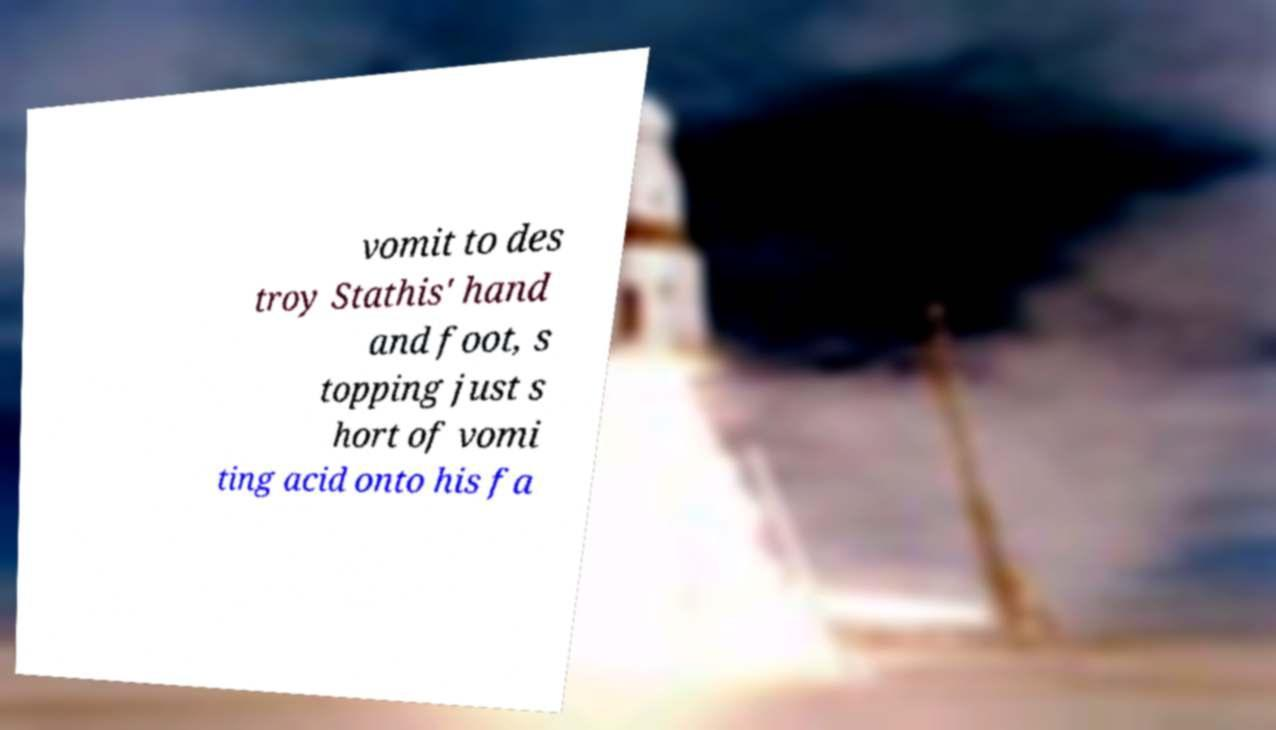Please identify and transcribe the text found in this image. vomit to des troy Stathis' hand and foot, s topping just s hort of vomi ting acid onto his fa 